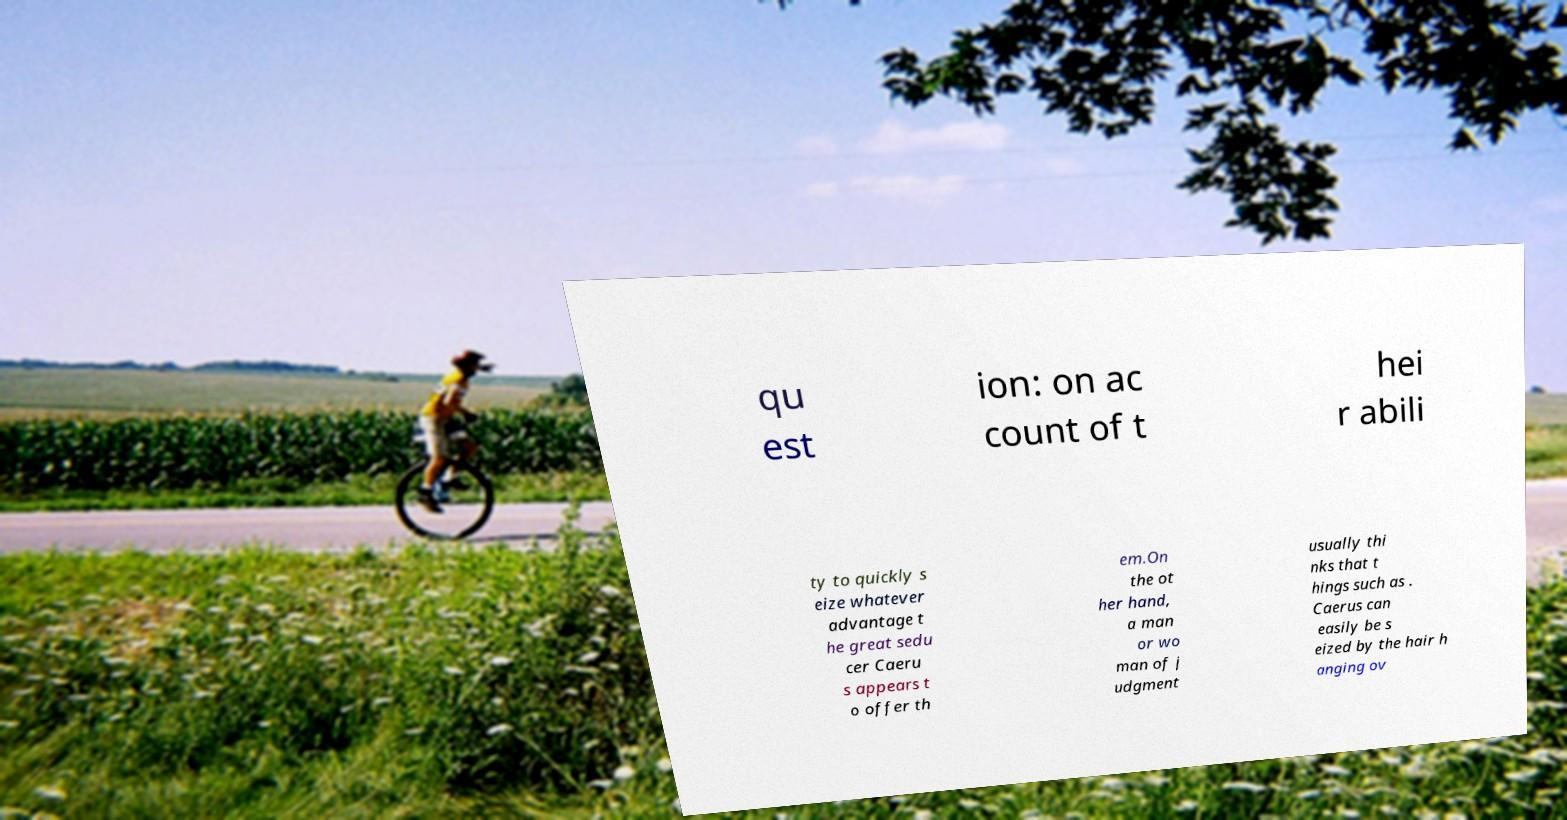Could you assist in decoding the text presented in this image and type it out clearly? qu est ion: on ac count of t hei r abili ty to quickly s eize whatever advantage t he great sedu cer Caeru s appears t o offer th em.On the ot her hand, a man or wo man of j udgment usually thi nks that t hings such as . Caerus can easily be s eized by the hair h anging ov 